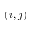Convert formula to latex. <formula><loc_0><loc_0><loc_500><loc_500>( i , j )</formula> 